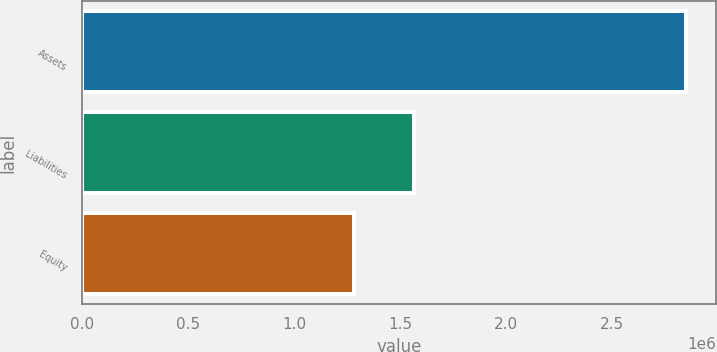Convert chart to OTSL. <chart><loc_0><loc_0><loc_500><loc_500><bar_chart><fcel>Assets<fcel>Liabilities<fcel>Equity<nl><fcel>2.84682e+06<fcel>1.56515e+06<fcel>1.28167e+06<nl></chart> 